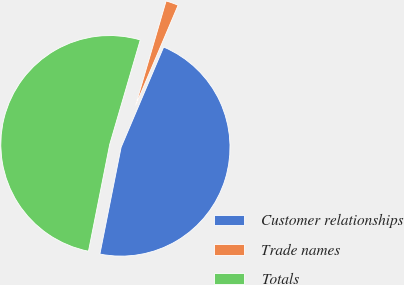Convert chart. <chart><loc_0><loc_0><loc_500><loc_500><pie_chart><fcel>Customer relationships<fcel>Trade names<fcel>Totals<nl><fcel>46.74%<fcel>1.86%<fcel>51.41%<nl></chart> 